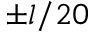Convert formula to latex. <formula><loc_0><loc_0><loc_500><loc_500>\pm l / 2 0</formula> 